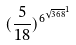<formula> <loc_0><loc_0><loc_500><loc_500>( \frac { 5 } { 1 8 } ) ^ { { 6 ^ { \sqrt { 3 6 8 } } } ^ { 1 } }</formula> 